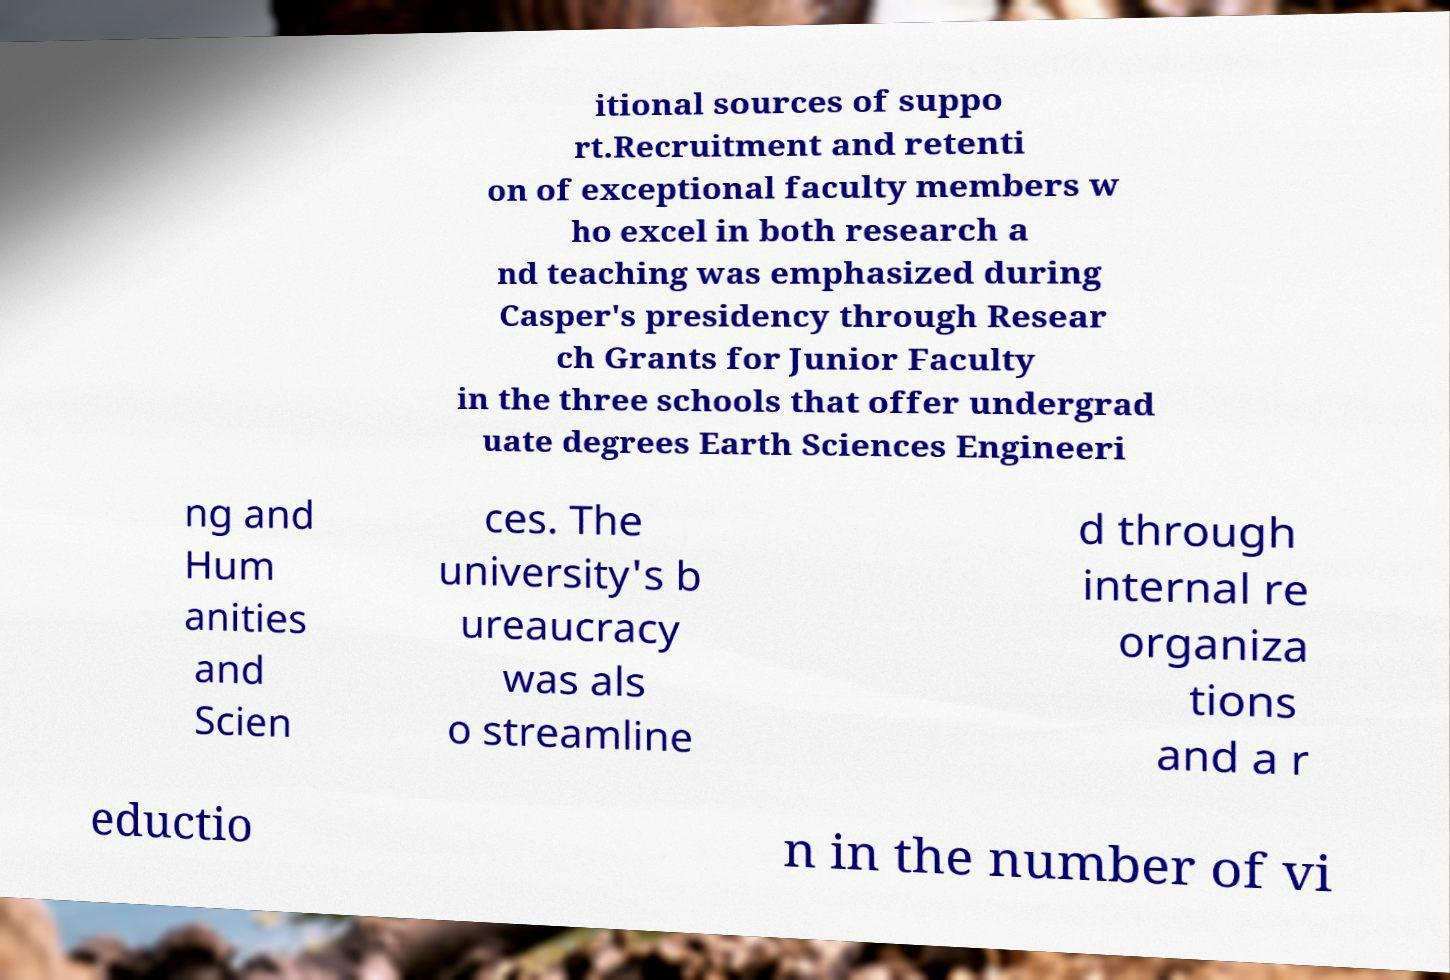Please read and relay the text visible in this image. What does it say? itional sources of suppo rt.Recruitment and retenti on of exceptional faculty members w ho excel in both research a nd teaching was emphasized during Casper's presidency through Resear ch Grants for Junior Faculty in the three schools that offer undergrad uate degrees Earth Sciences Engineeri ng and Hum anities and Scien ces. The university's b ureaucracy was als o streamline d through internal re organiza tions and a r eductio n in the number of vi 